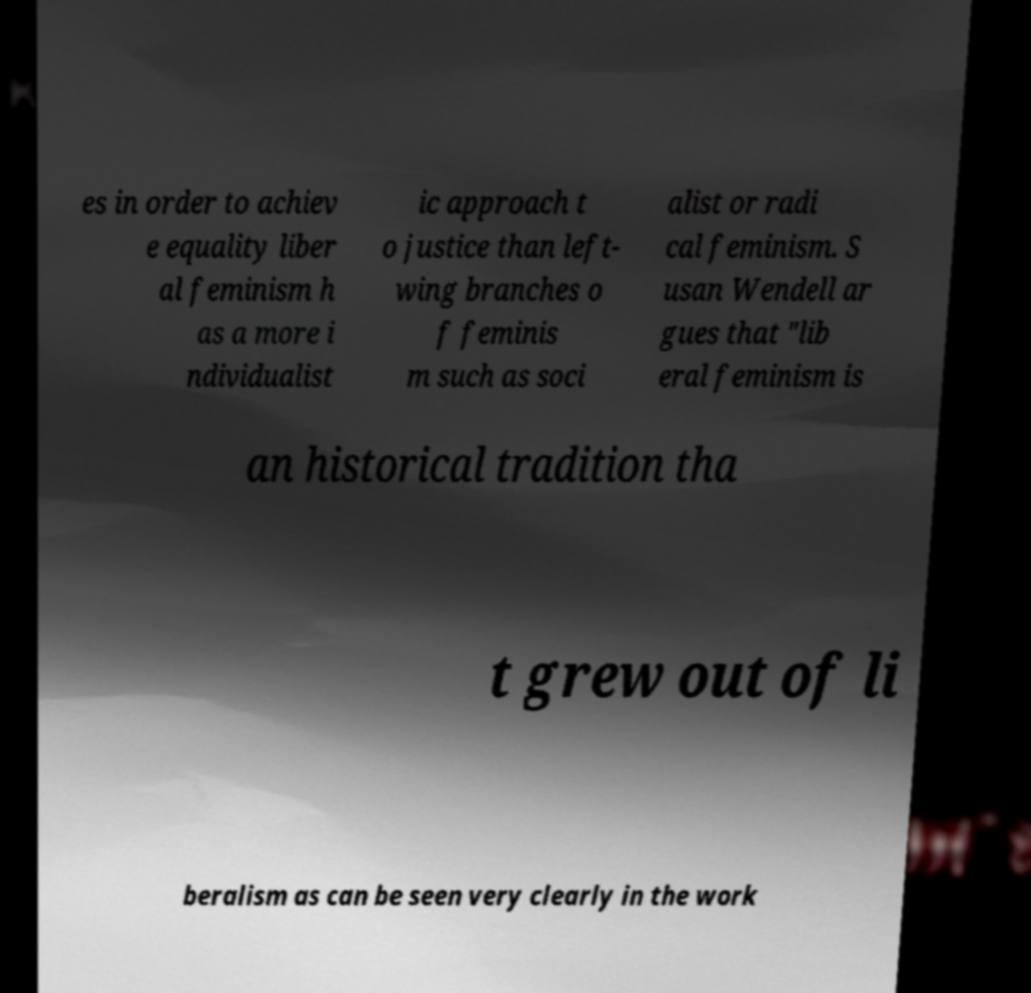Can you read and provide the text displayed in the image?This photo seems to have some interesting text. Can you extract and type it out for me? es in order to achiev e equality liber al feminism h as a more i ndividualist ic approach t o justice than left- wing branches o f feminis m such as soci alist or radi cal feminism. S usan Wendell ar gues that "lib eral feminism is an historical tradition tha t grew out of li beralism as can be seen very clearly in the work 